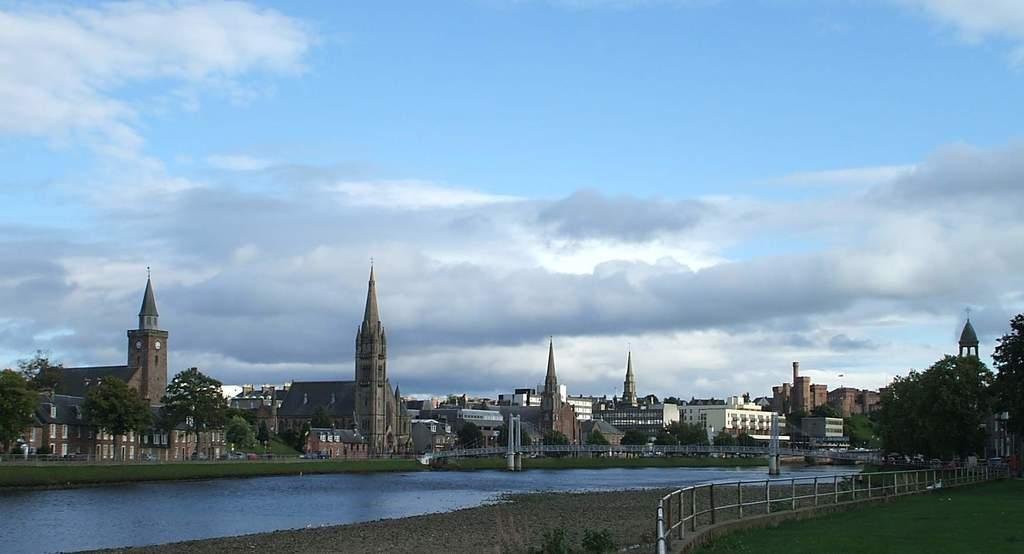What type of vegetation is on the right side of the image? There is a grass lawn on the right side of the image. What structure can be seen in the image? There is a railing in the image. What other natural elements are present in the image? There are trees in the image. What can be seen in the background of the image? There is water, buildings, trees, and the sky visible in the background of the image. What is the condition of the sky in the image? Clouds are visible in the sky. What type of silk is being used to make the tail of the snake in the image? There is no snake or silk present in the image. How many snakes are visible in the image? There are no snakes visible in the image. 